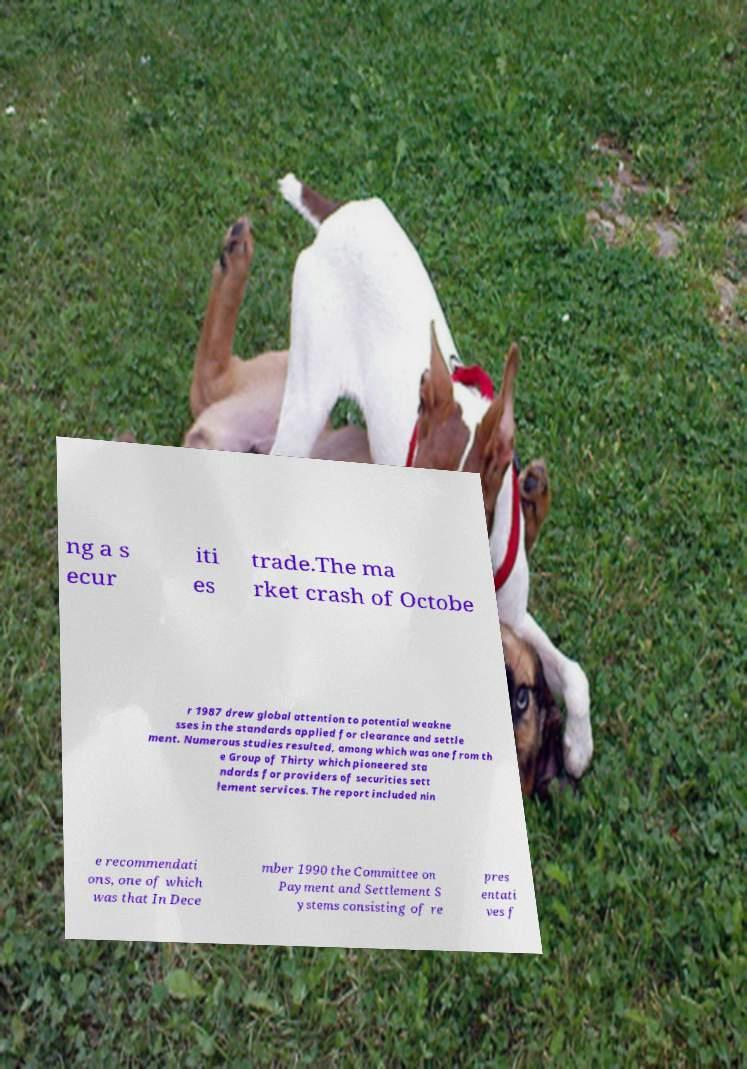Please identify and transcribe the text found in this image. ng a s ecur iti es trade.The ma rket crash of Octobe r 1987 drew global attention to potential weakne sses in the standards applied for clearance and settle ment. Numerous studies resulted, among which was one from th e Group of Thirty which pioneered sta ndards for providers of securities sett lement services. The report included nin e recommendati ons, one of which was that In Dece mber 1990 the Committee on Payment and Settlement S ystems consisting of re pres entati ves f 